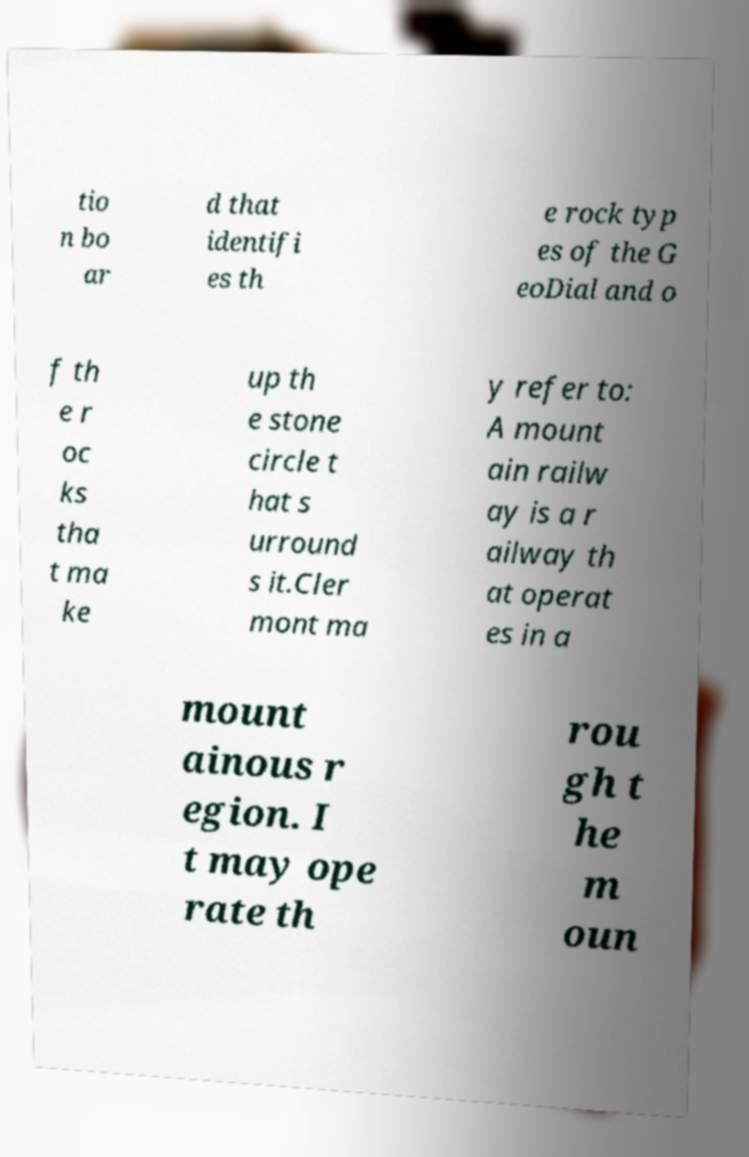Could you assist in decoding the text presented in this image and type it out clearly? tio n bo ar d that identifi es th e rock typ es of the G eoDial and o f th e r oc ks tha t ma ke up th e stone circle t hat s urround s it.Cler mont ma y refer to: A mount ain railw ay is a r ailway th at operat es in a mount ainous r egion. I t may ope rate th rou gh t he m oun 